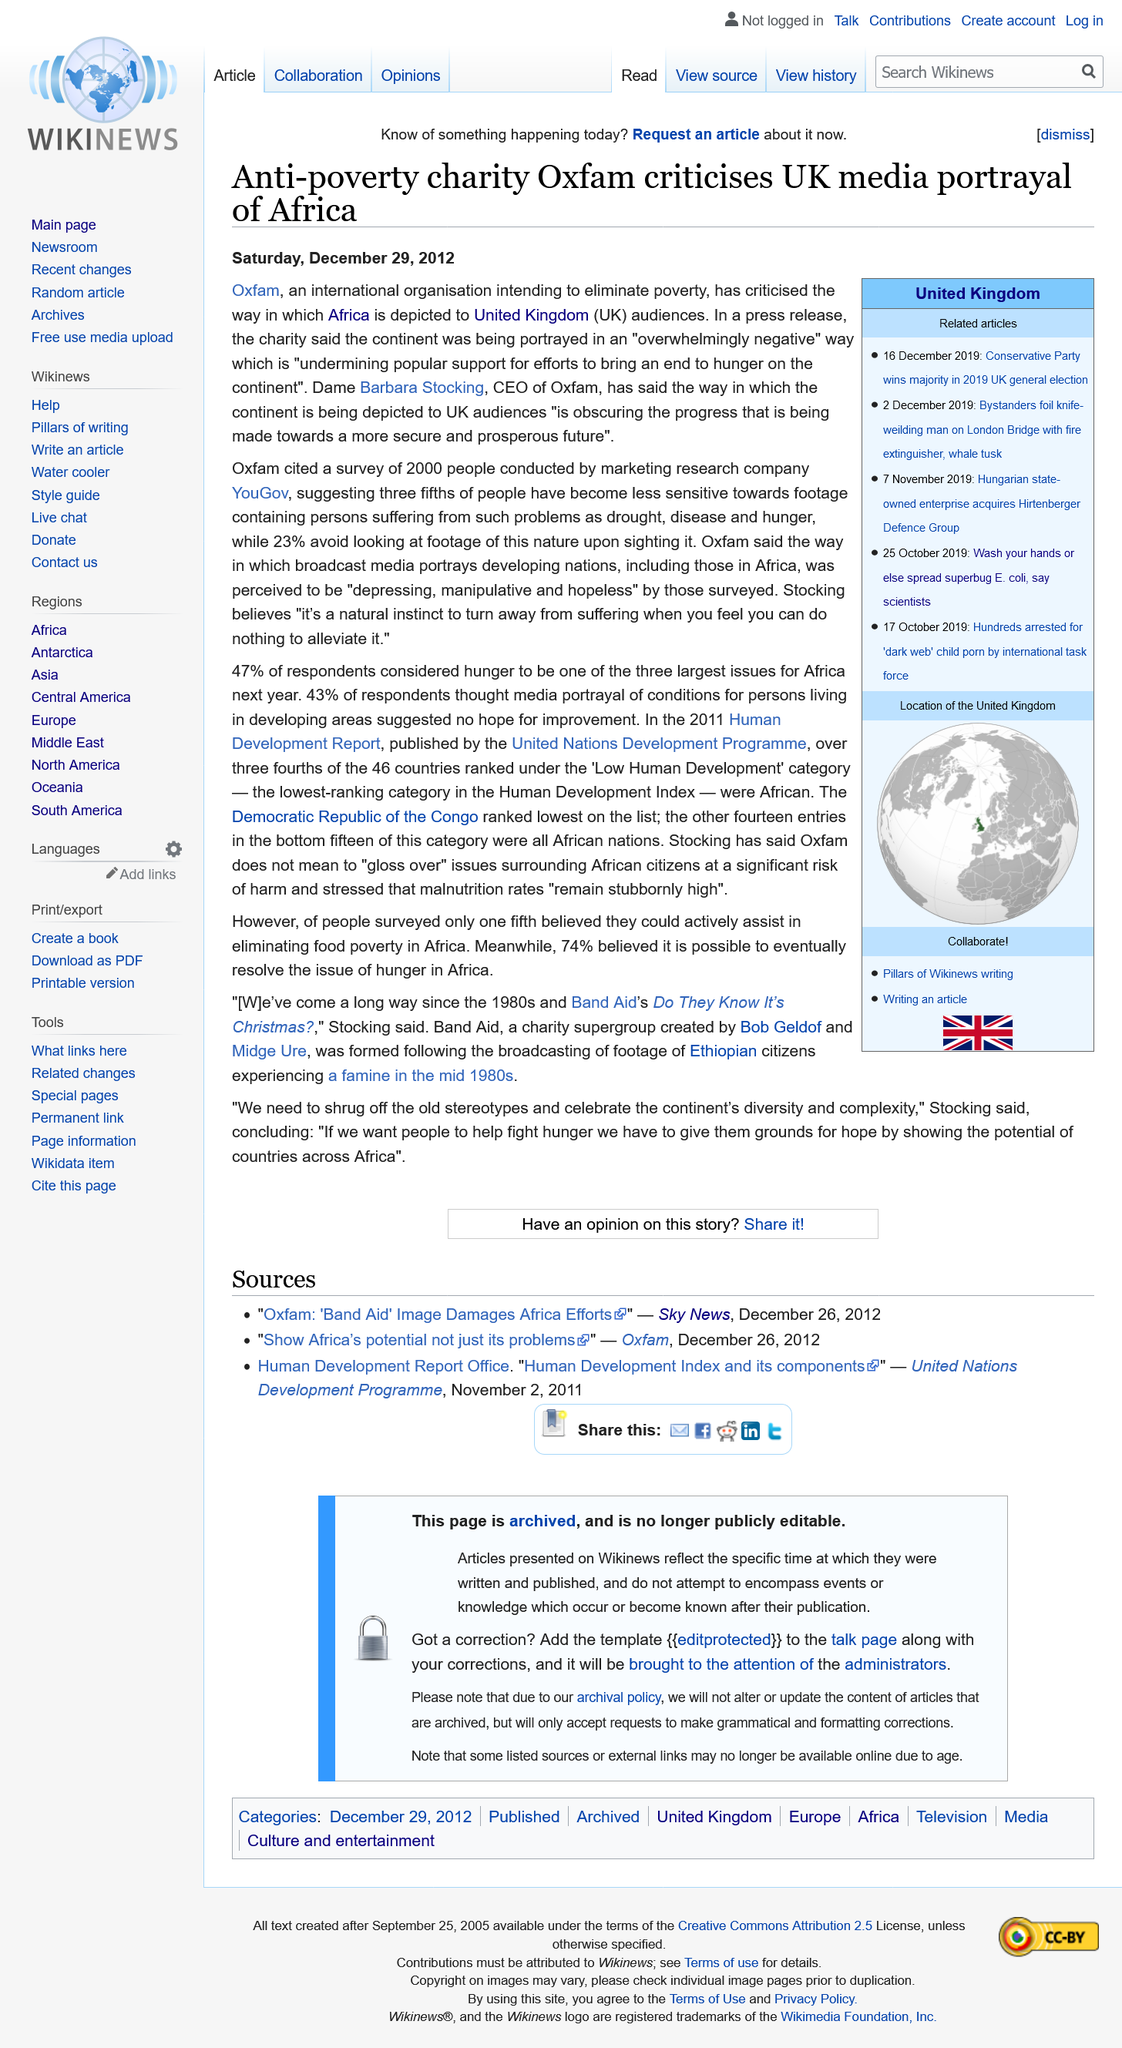List a handful of essential elements in this visual. Oxfam believes that Africa is being depicted in a negative way by the media. It is confirmed that Dame Barbara Stocking is the CEO of Oxfam. In a recent YouGov survey, 23% of people reported avoiding looking at footage containing suffering. 